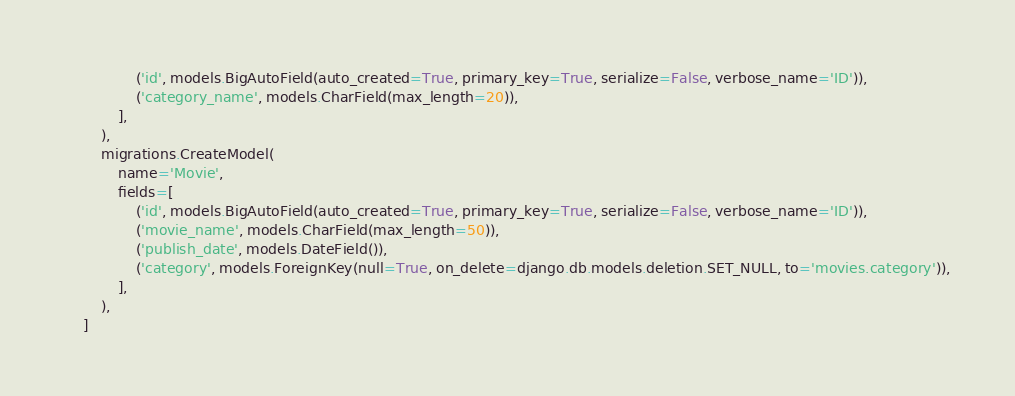Convert code to text. <code><loc_0><loc_0><loc_500><loc_500><_Python_>                ('id', models.BigAutoField(auto_created=True, primary_key=True, serialize=False, verbose_name='ID')),
                ('category_name', models.CharField(max_length=20)),
            ],
        ),
        migrations.CreateModel(
            name='Movie',
            fields=[
                ('id', models.BigAutoField(auto_created=True, primary_key=True, serialize=False, verbose_name='ID')),
                ('movie_name', models.CharField(max_length=50)),
                ('publish_date', models.DateField()),
                ('category', models.ForeignKey(null=True, on_delete=django.db.models.deletion.SET_NULL, to='movies.category')),
            ],
        ),
    ]
</code> 